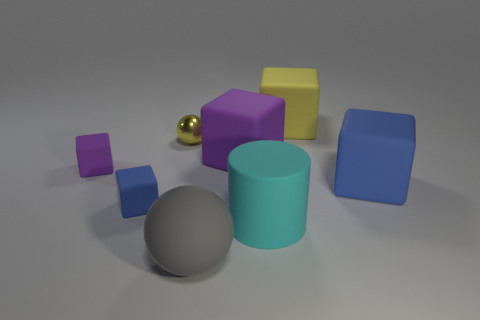Is there any other thing that is the same material as the tiny sphere?
Your response must be concise. No. The large rubber thing that is the same color as the shiny sphere is what shape?
Offer a very short reply. Cube. Is the color of the small metallic object the same as the large block behind the large purple rubber cube?
Your answer should be compact. Yes. What size is the cube that is the same color as the small metallic thing?
Provide a succinct answer. Large. Are there any rubber objects that have the same color as the tiny metal sphere?
Give a very brief answer. Yes. Is the shape of the blue rubber object that is to the right of the gray ball the same as the purple thing to the right of the tiny yellow object?
Provide a short and direct response. Yes. There is another thing that is the same shape as the gray matte thing; what is its material?
Keep it short and to the point. Metal. What is the material of the big block that is the same color as the tiny ball?
Ensure brevity in your answer.  Rubber. There is a large matte object that is behind the small metal sphere; is its color the same as the ball that is on the left side of the gray rubber object?
Keep it short and to the point. Yes. There is a big rubber thing that is left of the purple rubber thing that is on the right side of the tiny block behind the tiny blue thing; what shape is it?
Offer a very short reply. Sphere. 